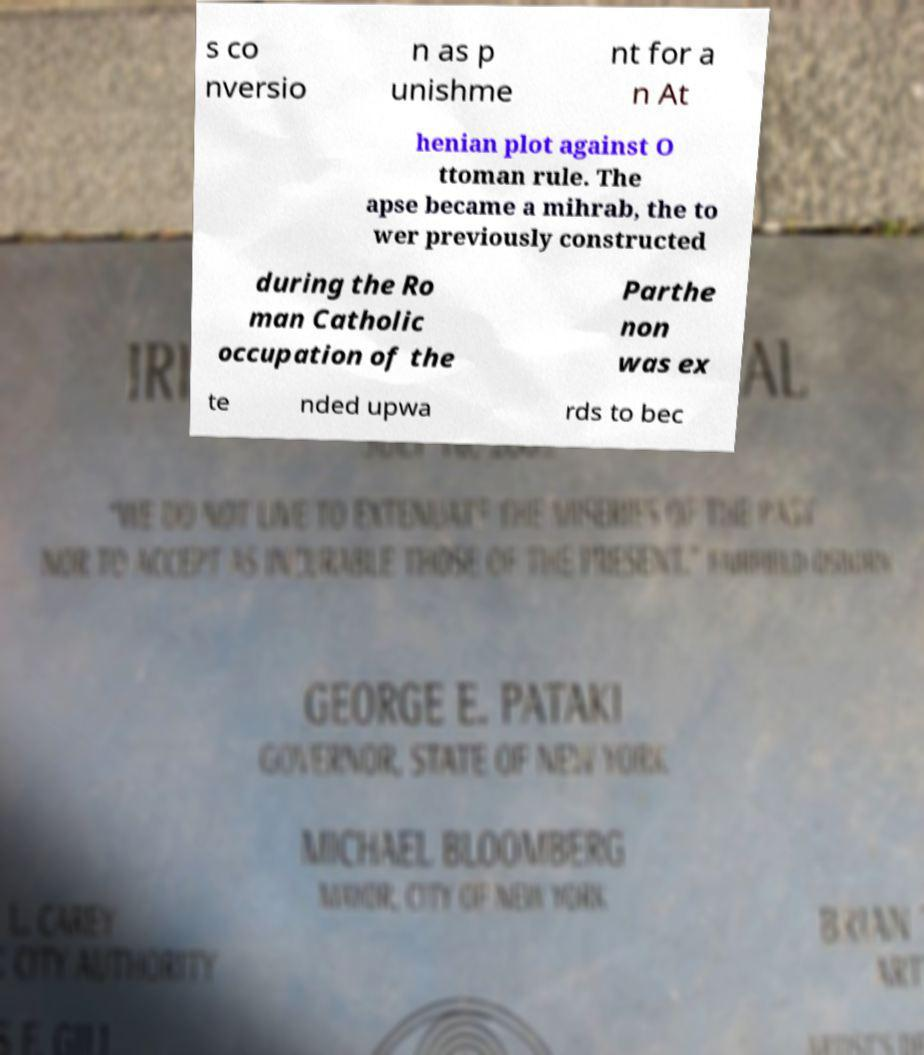Could you assist in decoding the text presented in this image and type it out clearly? s co nversio n as p unishme nt for a n At henian plot against O ttoman rule. The apse became a mihrab, the to wer previously constructed during the Ro man Catholic occupation of the Parthe non was ex te nded upwa rds to bec 